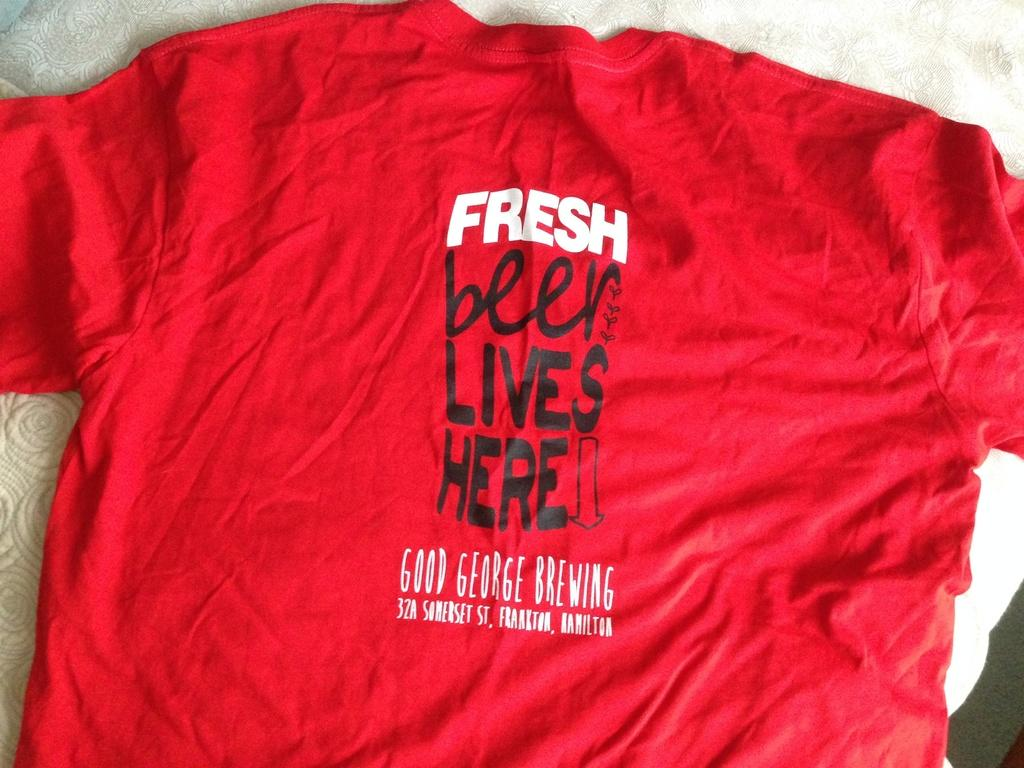Provide a one-sentence caption for the provided image. Red T shirt that says fresh beer lives here. 